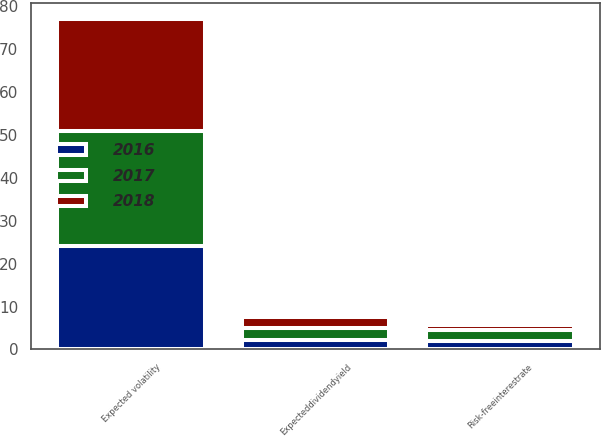Convert chart to OTSL. <chart><loc_0><loc_0><loc_500><loc_500><stacked_bar_chart><ecel><fcel>Risk-freeinterestrate<fcel>Expecteddividendyield<fcel>Expected volatility<nl><fcel>2017<fcel>2.57<fcel>2.57<fcel>27<nl><fcel>2016<fcel>1.85<fcel>2.31<fcel>24<nl><fcel>2018<fcel>1.16<fcel>2.74<fcel>26<nl></chart> 